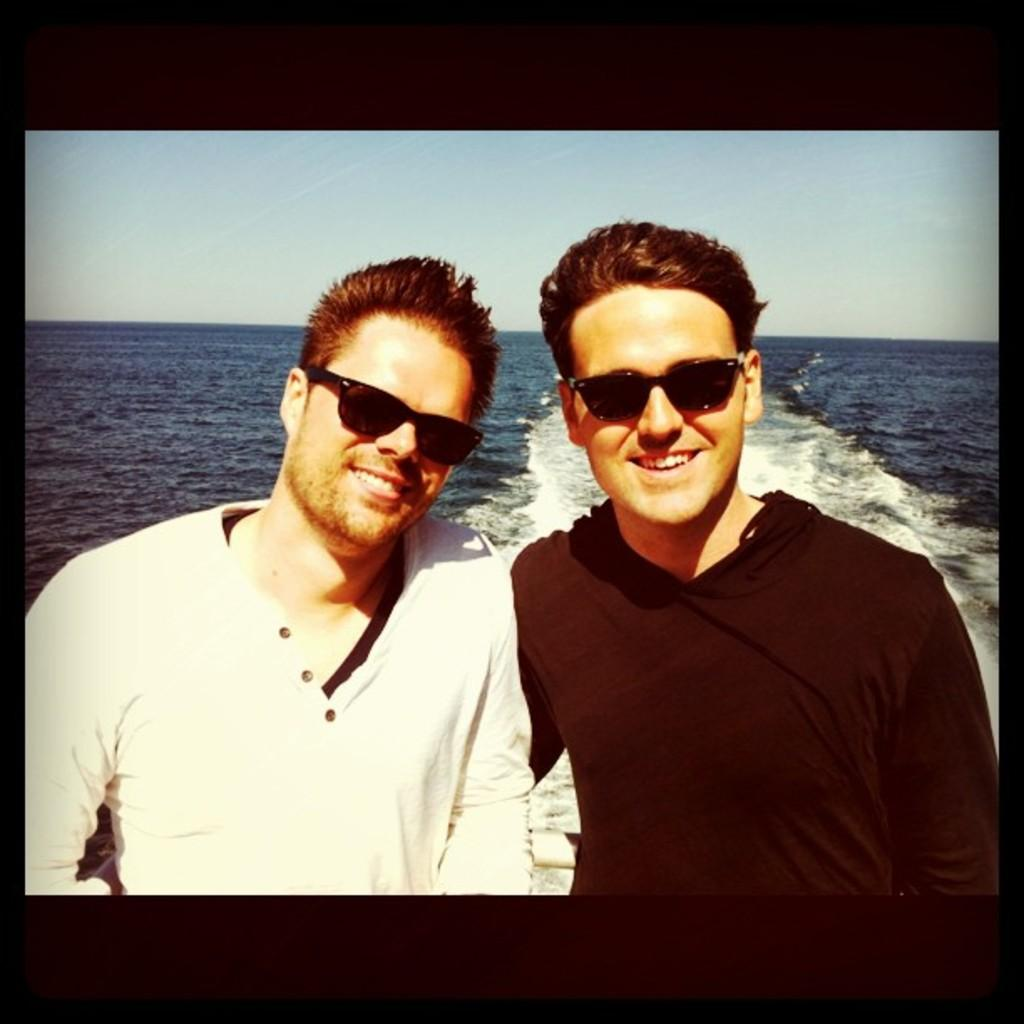How many people are in the image? There are two persons in the image. What are the persons wearing? The persons are wearing clothes and sunglasses. What can be seen in the middle of the image? There is a sea in the middle of the image. What is visible at the top of the image? There is a sky at the top of the image. Where is the kitten playing with a sack in the image? There is no kitten or sack present in the image. What type of trade is being conducted in the image? There is no trade being conducted in the image; it features two persons and a sea. 